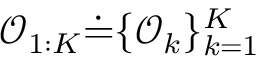Convert formula to latex. <formula><loc_0><loc_0><loc_500><loc_500>\mathcal { O } _ { 1 \colon K } \dot { = } \{ \mathcal { O } _ { k } \} _ { k = 1 } ^ { K }</formula> 